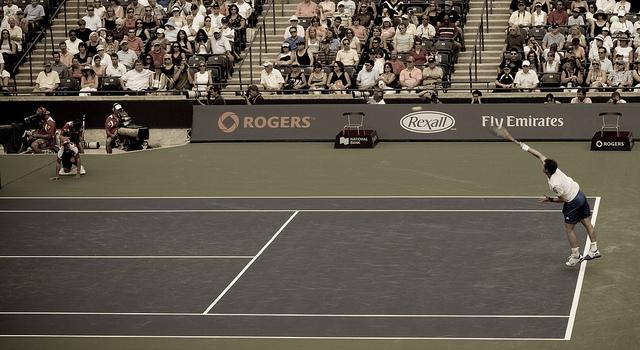What does Fly Emirates provide to the game? sponsorship 